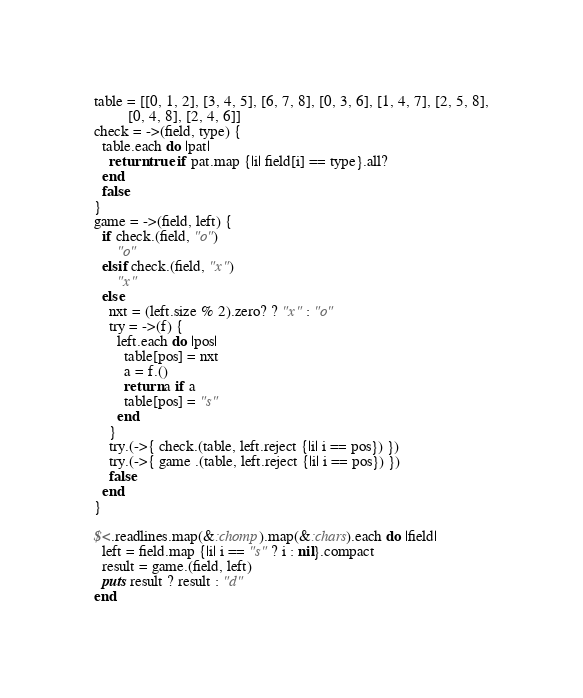Convert code to text. <code><loc_0><loc_0><loc_500><loc_500><_Ruby_>table = [[0, 1, 2], [3, 4, 5], [6, 7, 8], [0, 3, 6], [1, 4, 7], [2, 5, 8],
         [0, 4, 8], [2, 4, 6]]
check = ->(field, type) {
  table.each do |pat|
    return true if pat.map {|i| field[i] == type}.all?
  end
  false
}
game = ->(field, left) {
  if check.(field, "o")
      "o"
  elsif check.(field, "x")
      "x"
  else
    nxt = (left.size % 2).zero? ? "x" : "o"
    try = ->(f) {
      left.each do |pos|
        table[pos] = nxt
        a = f.()
        return a if a
        table[pos] = "s"
      end
    }
    try.(->{ check.(table, left.reject {|i| i == pos}) })
    try.(->{ game .(table, left.reject {|i| i == pos}) })
    false
  end
}
         
$<.readlines.map(&:chomp).map(&:chars).each do |field|
  left = field.map {|i| i == "s" ? i : nil}.compact
  result = game.(field, left)
  puts result ? result : "d"
end
</code> 